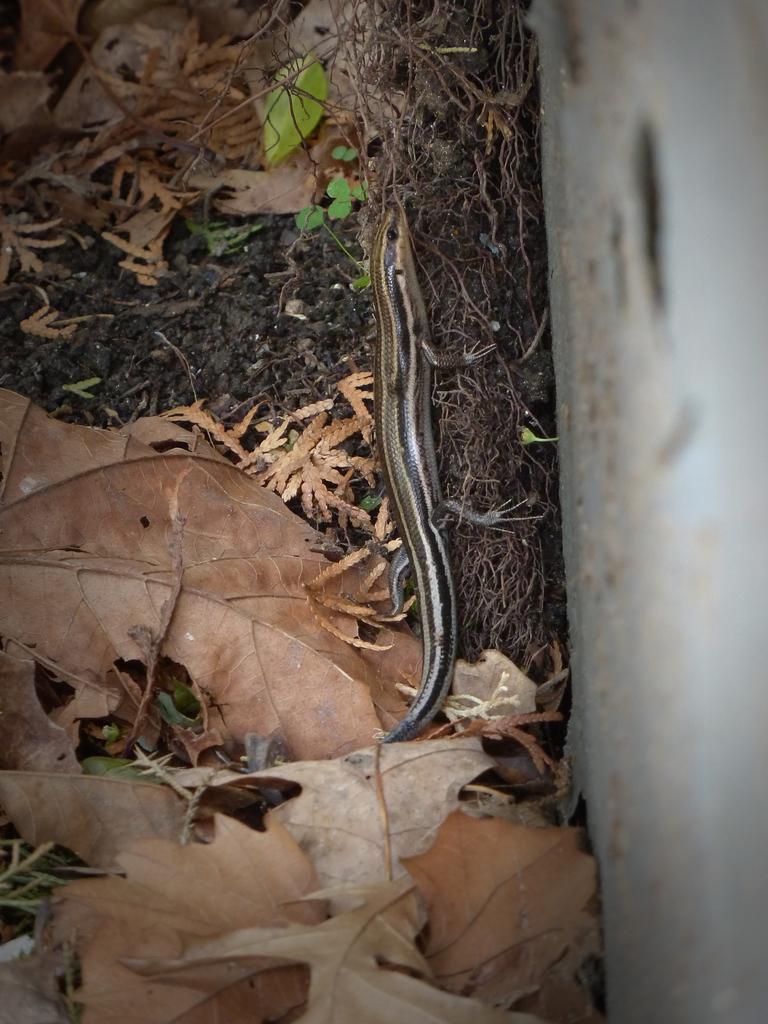How would you summarize this image in a sentence or two? In this image I can see the ground, few leaves on the ground and a reptile which is brown, black and white in color on the ground. To the right side of the image I can see the white colored surface. 